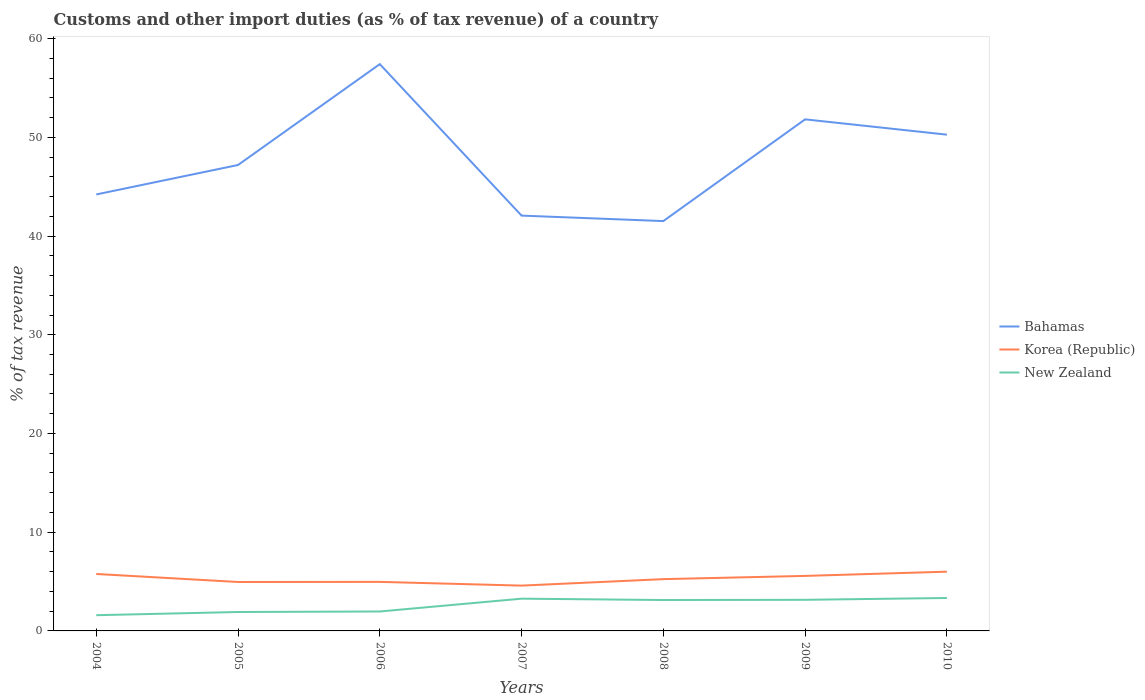Is the number of lines equal to the number of legend labels?
Your response must be concise. Yes. Across all years, what is the maximum percentage of tax revenue from customs in Korea (Republic)?
Your answer should be very brief. 4.59. What is the total percentage of tax revenue from customs in Bahamas in the graph?
Your answer should be very brief. 7.14. What is the difference between the highest and the second highest percentage of tax revenue from customs in Bahamas?
Your response must be concise. 15.9. Is the percentage of tax revenue from customs in New Zealand strictly greater than the percentage of tax revenue from customs in Bahamas over the years?
Your answer should be very brief. Yes. How many years are there in the graph?
Ensure brevity in your answer.  7. Does the graph contain any zero values?
Give a very brief answer. No. Where does the legend appear in the graph?
Keep it short and to the point. Center right. What is the title of the graph?
Offer a very short reply. Customs and other import duties (as % of tax revenue) of a country. Does "Brunei Darussalam" appear as one of the legend labels in the graph?
Offer a very short reply. No. What is the label or title of the X-axis?
Ensure brevity in your answer.  Years. What is the label or title of the Y-axis?
Ensure brevity in your answer.  % of tax revenue. What is the % of tax revenue in Bahamas in 2004?
Your answer should be compact. 44.21. What is the % of tax revenue in Korea (Republic) in 2004?
Give a very brief answer. 5.77. What is the % of tax revenue in New Zealand in 2004?
Ensure brevity in your answer.  1.59. What is the % of tax revenue in Bahamas in 2005?
Offer a very short reply. 47.2. What is the % of tax revenue of Korea (Republic) in 2005?
Offer a terse response. 4.96. What is the % of tax revenue in New Zealand in 2005?
Make the answer very short. 1.92. What is the % of tax revenue of Bahamas in 2006?
Make the answer very short. 57.42. What is the % of tax revenue of Korea (Republic) in 2006?
Provide a short and direct response. 4.97. What is the % of tax revenue in New Zealand in 2006?
Keep it short and to the point. 1.97. What is the % of tax revenue of Bahamas in 2007?
Your response must be concise. 42.07. What is the % of tax revenue of Korea (Republic) in 2007?
Your answer should be very brief. 4.59. What is the % of tax revenue of New Zealand in 2007?
Your answer should be compact. 3.27. What is the % of tax revenue of Bahamas in 2008?
Your answer should be very brief. 41.52. What is the % of tax revenue of Korea (Republic) in 2008?
Offer a very short reply. 5.25. What is the % of tax revenue of New Zealand in 2008?
Provide a short and direct response. 3.13. What is the % of tax revenue in Bahamas in 2009?
Provide a short and direct response. 51.82. What is the % of tax revenue in Korea (Republic) in 2009?
Offer a very short reply. 5.57. What is the % of tax revenue in New Zealand in 2009?
Provide a short and direct response. 3.15. What is the % of tax revenue of Bahamas in 2010?
Your answer should be very brief. 50.27. What is the % of tax revenue of Korea (Republic) in 2010?
Make the answer very short. 6. What is the % of tax revenue in New Zealand in 2010?
Provide a short and direct response. 3.34. Across all years, what is the maximum % of tax revenue of Bahamas?
Ensure brevity in your answer.  57.42. Across all years, what is the maximum % of tax revenue in Korea (Republic)?
Ensure brevity in your answer.  6. Across all years, what is the maximum % of tax revenue of New Zealand?
Provide a short and direct response. 3.34. Across all years, what is the minimum % of tax revenue in Bahamas?
Your answer should be compact. 41.52. Across all years, what is the minimum % of tax revenue in Korea (Republic)?
Offer a terse response. 4.59. Across all years, what is the minimum % of tax revenue in New Zealand?
Provide a succinct answer. 1.59. What is the total % of tax revenue in Bahamas in the graph?
Provide a short and direct response. 334.51. What is the total % of tax revenue in Korea (Republic) in the graph?
Your response must be concise. 37.1. What is the total % of tax revenue in New Zealand in the graph?
Your answer should be compact. 18.36. What is the difference between the % of tax revenue of Bahamas in 2004 and that in 2005?
Offer a very short reply. -2.98. What is the difference between the % of tax revenue of Korea (Republic) in 2004 and that in 2005?
Make the answer very short. 0.81. What is the difference between the % of tax revenue of New Zealand in 2004 and that in 2005?
Offer a terse response. -0.32. What is the difference between the % of tax revenue of Bahamas in 2004 and that in 2006?
Provide a succinct answer. -13.2. What is the difference between the % of tax revenue of Korea (Republic) in 2004 and that in 2006?
Provide a short and direct response. 0.8. What is the difference between the % of tax revenue of New Zealand in 2004 and that in 2006?
Offer a terse response. -0.38. What is the difference between the % of tax revenue of Bahamas in 2004 and that in 2007?
Offer a terse response. 2.14. What is the difference between the % of tax revenue of Korea (Republic) in 2004 and that in 2007?
Give a very brief answer. 1.18. What is the difference between the % of tax revenue of New Zealand in 2004 and that in 2007?
Give a very brief answer. -1.67. What is the difference between the % of tax revenue in Bahamas in 2004 and that in 2008?
Your answer should be very brief. 2.7. What is the difference between the % of tax revenue of Korea (Republic) in 2004 and that in 2008?
Give a very brief answer. 0.52. What is the difference between the % of tax revenue of New Zealand in 2004 and that in 2008?
Your answer should be compact. -1.54. What is the difference between the % of tax revenue of Bahamas in 2004 and that in 2009?
Keep it short and to the point. -7.61. What is the difference between the % of tax revenue of Korea (Republic) in 2004 and that in 2009?
Provide a short and direct response. 0.2. What is the difference between the % of tax revenue of New Zealand in 2004 and that in 2009?
Give a very brief answer. -1.56. What is the difference between the % of tax revenue of Bahamas in 2004 and that in 2010?
Keep it short and to the point. -6.06. What is the difference between the % of tax revenue in Korea (Republic) in 2004 and that in 2010?
Your answer should be very brief. -0.23. What is the difference between the % of tax revenue of New Zealand in 2004 and that in 2010?
Your response must be concise. -1.74. What is the difference between the % of tax revenue of Bahamas in 2005 and that in 2006?
Your answer should be compact. -10.22. What is the difference between the % of tax revenue of Korea (Republic) in 2005 and that in 2006?
Keep it short and to the point. -0.01. What is the difference between the % of tax revenue in New Zealand in 2005 and that in 2006?
Your response must be concise. -0.05. What is the difference between the % of tax revenue of Bahamas in 2005 and that in 2007?
Make the answer very short. 5.13. What is the difference between the % of tax revenue of Korea (Republic) in 2005 and that in 2007?
Offer a very short reply. 0.37. What is the difference between the % of tax revenue of New Zealand in 2005 and that in 2007?
Your response must be concise. -1.35. What is the difference between the % of tax revenue in Bahamas in 2005 and that in 2008?
Keep it short and to the point. 5.68. What is the difference between the % of tax revenue in Korea (Republic) in 2005 and that in 2008?
Provide a succinct answer. -0.29. What is the difference between the % of tax revenue of New Zealand in 2005 and that in 2008?
Give a very brief answer. -1.21. What is the difference between the % of tax revenue in Bahamas in 2005 and that in 2009?
Offer a very short reply. -4.62. What is the difference between the % of tax revenue in Korea (Republic) in 2005 and that in 2009?
Make the answer very short. -0.62. What is the difference between the % of tax revenue of New Zealand in 2005 and that in 2009?
Keep it short and to the point. -1.23. What is the difference between the % of tax revenue in Bahamas in 2005 and that in 2010?
Your answer should be very brief. -3.07. What is the difference between the % of tax revenue of Korea (Republic) in 2005 and that in 2010?
Your response must be concise. -1.05. What is the difference between the % of tax revenue of New Zealand in 2005 and that in 2010?
Provide a succinct answer. -1.42. What is the difference between the % of tax revenue in Bahamas in 2006 and that in 2007?
Offer a very short reply. 15.35. What is the difference between the % of tax revenue of Korea (Republic) in 2006 and that in 2007?
Provide a succinct answer. 0.38. What is the difference between the % of tax revenue in New Zealand in 2006 and that in 2007?
Your answer should be compact. -1.3. What is the difference between the % of tax revenue in Bahamas in 2006 and that in 2008?
Make the answer very short. 15.9. What is the difference between the % of tax revenue of Korea (Republic) in 2006 and that in 2008?
Offer a very short reply. -0.28. What is the difference between the % of tax revenue in New Zealand in 2006 and that in 2008?
Make the answer very short. -1.16. What is the difference between the % of tax revenue of Bahamas in 2006 and that in 2009?
Give a very brief answer. 5.59. What is the difference between the % of tax revenue of Korea (Republic) in 2006 and that in 2009?
Offer a very short reply. -0.6. What is the difference between the % of tax revenue of New Zealand in 2006 and that in 2009?
Your response must be concise. -1.18. What is the difference between the % of tax revenue in Bahamas in 2006 and that in 2010?
Keep it short and to the point. 7.14. What is the difference between the % of tax revenue in Korea (Republic) in 2006 and that in 2010?
Offer a very short reply. -1.03. What is the difference between the % of tax revenue in New Zealand in 2006 and that in 2010?
Provide a short and direct response. -1.37. What is the difference between the % of tax revenue of Bahamas in 2007 and that in 2008?
Your answer should be compact. 0.55. What is the difference between the % of tax revenue in Korea (Republic) in 2007 and that in 2008?
Your answer should be very brief. -0.66. What is the difference between the % of tax revenue of New Zealand in 2007 and that in 2008?
Give a very brief answer. 0.14. What is the difference between the % of tax revenue in Bahamas in 2007 and that in 2009?
Your answer should be very brief. -9.75. What is the difference between the % of tax revenue of Korea (Republic) in 2007 and that in 2009?
Offer a very short reply. -0.98. What is the difference between the % of tax revenue in New Zealand in 2007 and that in 2009?
Your response must be concise. 0.11. What is the difference between the % of tax revenue in Bahamas in 2007 and that in 2010?
Ensure brevity in your answer.  -8.2. What is the difference between the % of tax revenue in Korea (Republic) in 2007 and that in 2010?
Keep it short and to the point. -1.41. What is the difference between the % of tax revenue of New Zealand in 2007 and that in 2010?
Your answer should be compact. -0.07. What is the difference between the % of tax revenue of Bahamas in 2008 and that in 2009?
Your answer should be very brief. -10.3. What is the difference between the % of tax revenue of Korea (Republic) in 2008 and that in 2009?
Keep it short and to the point. -0.33. What is the difference between the % of tax revenue of New Zealand in 2008 and that in 2009?
Give a very brief answer. -0.02. What is the difference between the % of tax revenue of Bahamas in 2008 and that in 2010?
Provide a succinct answer. -8.75. What is the difference between the % of tax revenue in Korea (Republic) in 2008 and that in 2010?
Provide a short and direct response. -0.76. What is the difference between the % of tax revenue of New Zealand in 2008 and that in 2010?
Your answer should be very brief. -0.21. What is the difference between the % of tax revenue of Bahamas in 2009 and that in 2010?
Your answer should be compact. 1.55. What is the difference between the % of tax revenue in Korea (Republic) in 2009 and that in 2010?
Your response must be concise. -0.43. What is the difference between the % of tax revenue in New Zealand in 2009 and that in 2010?
Make the answer very short. -0.18. What is the difference between the % of tax revenue in Bahamas in 2004 and the % of tax revenue in Korea (Republic) in 2005?
Offer a very short reply. 39.26. What is the difference between the % of tax revenue in Bahamas in 2004 and the % of tax revenue in New Zealand in 2005?
Your response must be concise. 42.3. What is the difference between the % of tax revenue in Korea (Republic) in 2004 and the % of tax revenue in New Zealand in 2005?
Make the answer very short. 3.85. What is the difference between the % of tax revenue of Bahamas in 2004 and the % of tax revenue of Korea (Republic) in 2006?
Ensure brevity in your answer.  39.25. What is the difference between the % of tax revenue of Bahamas in 2004 and the % of tax revenue of New Zealand in 2006?
Give a very brief answer. 42.25. What is the difference between the % of tax revenue in Korea (Republic) in 2004 and the % of tax revenue in New Zealand in 2006?
Give a very brief answer. 3.8. What is the difference between the % of tax revenue in Bahamas in 2004 and the % of tax revenue in Korea (Republic) in 2007?
Your response must be concise. 39.62. What is the difference between the % of tax revenue in Bahamas in 2004 and the % of tax revenue in New Zealand in 2007?
Offer a very short reply. 40.95. What is the difference between the % of tax revenue of Korea (Republic) in 2004 and the % of tax revenue of New Zealand in 2007?
Your answer should be compact. 2.5. What is the difference between the % of tax revenue in Bahamas in 2004 and the % of tax revenue in Korea (Republic) in 2008?
Ensure brevity in your answer.  38.97. What is the difference between the % of tax revenue of Bahamas in 2004 and the % of tax revenue of New Zealand in 2008?
Give a very brief answer. 41.08. What is the difference between the % of tax revenue of Korea (Republic) in 2004 and the % of tax revenue of New Zealand in 2008?
Give a very brief answer. 2.64. What is the difference between the % of tax revenue in Bahamas in 2004 and the % of tax revenue in Korea (Republic) in 2009?
Make the answer very short. 38.64. What is the difference between the % of tax revenue in Bahamas in 2004 and the % of tax revenue in New Zealand in 2009?
Your response must be concise. 41.06. What is the difference between the % of tax revenue in Korea (Republic) in 2004 and the % of tax revenue in New Zealand in 2009?
Provide a short and direct response. 2.62. What is the difference between the % of tax revenue in Bahamas in 2004 and the % of tax revenue in Korea (Republic) in 2010?
Provide a succinct answer. 38.21. What is the difference between the % of tax revenue of Bahamas in 2004 and the % of tax revenue of New Zealand in 2010?
Your answer should be very brief. 40.88. What is the difference between the % of tax revenue in Korea (Republic) in 2004 and the % of tax revenue in New Zealand in 2010?
Provide a short and direct response. 2.43. What is the difference between the % of tax revenue of Bahamas in 2005 and the % of tax revenue of Korea (Republic) in 2006?
Keep it short and to the point. 42.23. What is the difference between the % of tax revenue in Bahamas in 2005 and the % of tax revenue in New Zealand in 2006?
Keep it short and to the point. 45.23. What is the difference between the % of tax revenue in Korea (Republic) in 2005 and the % of tax revenue in New Zealand in 2006?
Offer a very short reply. 2.99. What is the difference between the % of tax revenue in Bahamas in 2005 and the % of tax revenue in Korea (Republic) in 2007?
Provide a succinct answer. 42.61. What is the difference between the % of tax revenue of Bahamas in 2005 and the % of tax revenue of New Zealand in 2007?
Your answer should be very brief. 43.93. What is the difference between the % of tax revenue in Korea (Republic) in 2005 and the % of tax revenue in New Zealand in 2007?
Offer a very short reply. 1.69. What is the difference between the % of tax revenue in Bahamas in 2005 and the % of tax revenue in Korea (Republic) in 2008?
Your answer should be compact. 41.95. What is the difference between the % of tax revenue in Bahamas in 2005 and the % of tax revenue in New Zealand in 2008?
Keep it short and to the point. 44.07. What is the difference between the % of tax revenue in Korea (Republic) in 2005 and the % of tax revenue in New Zealand in 2008?
Your answer should be very brief. 1.83. What is the difference between the % of tax revenue in Bahamas in 2005 and the % of tax revenue in Korea (Republic) in 2009?
Offer a very short reply. 41.62. What is the difference between the % of tax revenue of Bahamas in 2005 and the % of tax revenue of New Zealand in 2009?
Your response must be concise. 44.05. What is the difference between the % of tax revenue of Korea (Republic) in 2005 and the % of tax revenue of New Zealand in 2009?
Give a very brief answer. 1.8. What is the difference between the % of tax revenue in Bahamas in 2005 and the % of tax revenue in Korea (Republic) in 2010?
Offer a terse response. 41.2. What is the difference between the % of tax revenue in Bahamas in 2005 and the % of tax revenue in New Zealand in 2010?
Ensure brevity in your answer.  43.86. What is the difference between the % of tax revenue of Korea (Republic) in 2005 and the % of tax revenue of New Zealand in 2010?
Your response must be concise. 1.62. What is the difference between the % of tax revenue of Bahamas in 2006 and the % of tax revenue of Korea (Republic) in 2007?
Keep it short and to the point. 52.83. What is the difference between the % of tax revenue of Bahamas in 2006 and the % of tax revenue of New Zealand in 2007?
Your answer should be compact. 54.15. What is the difference between the % of tax revenue in Korea (Republic) in 2006 and the % of tax revenue in New Zealand in 2007?
Make the answer very short. 1.7. What is the difference between the % of tax revenue of Bahamas in 2006 and the % of tax revenue of Korea (Republic) in 2008?
Ensure brevity in your answer.  52.17. What is the difference between the % of tax revenue in Bahamas in 2006 and the % of tax revenue in New Zealand in 2008?
Your response must be concise. 54.28. What is the difference between the % of tax revenue in Korea (Republic) in 2006 and the % of tax revenue in New Zealand in 2008?
Offer a very short reply. 1.84. What is the difference between the % of tax revenue in Bahamas in 2006 and the % of tax revenue in Korea (Republic) in 2009?
Keep it short and to the point. 51.84. What is the difference between the % of tax revenue of Bahamas in 2006 and the % of tax revenue of New Zealand in 2009?
Provide a succinct answer. 54.26. What is the difference between the % of tax revenue of Korea (Republic) in 2006 and the % of tax revenue of New Zealand in 2009?
Offer a terse response. 1.82. What is the difference between the % of tax revenue in Bahamas in 2006 and the % of tax revenue in Korea (Republic) in 2010?
Offer a very short reply. 51.41. What is the difference between the % of tax revenue of Bahamas in 2006 and the % of tax revenue of New Zealand in 2010?
Your answer should be very brief. 54.08. What is the difference between the % of tax revenue in Korea (Republic) in 2006 and the % of tax revenue in New Zealand in 2010?
Offer a very short reply. 1.63. What is the difference between the % of tax revenue of Bahamas in 2007 and the % of tax revenue of Korea (Republic) in 2008?
Your response must be concise. 36.82. What is the difference between the % of tax revenue in Bahamas in 2007 and the % of tax revenue in New Zealand in 2008?
Your answer should be very brief. 38.94. What is the difference between the % of tax revenue in Korea (Republic) in 2007 and the % of tax revenue in New Zealand in 2008?
Your answer should be very brief. 1.46. What is the difference between the % of tax revenue in Bahamas in 2007 and the % of tax revenue in Korea (Republic) in 2009?
Offer a very short reply. 36.5. What is the difference between the % of tax revenue in Bahamas in 2007 and the % of tax revenue in New Zealand in 2009?
Provide a succinct answer. 38.92. What is the difference between the % of tax revenue of Korea (Republic) in 2007 and the % of tax revenue of New Zealand in 2009?
Make the answer very short. 1.44. What is the difference between the % of tax revenue in Bahamas in 2007 and the % of tax revenue in Korea (Republic) in 2010?
Your answer should be compact. 36.07. What is the difference between the % of tax revenue of Bahamas in 2007 and the % of tax revenue of New Zealand in 2010?
Provide a short and direct response. 38.73. What is the difference between the % of tax revenue in Korea (Republic) in 2007 and the % of tax revenue in New Zealand in 2010?
Give a very brief answer. 1.25. What is the difference between the % of tax revenue in Bahamas in 2008 and the % of tax revenue in Korea (Republic) in 2009?
Your answer should be compact. 35.94. What is the difference between the % of tax revenue in Bahamas in 2008 and the % of tax revenue in New Zealand in 2009?
Your answer should be very brief. 38.37. What is the difference between the % of tax revenue in Korea (Republic) in 2008 and the % of tax revenue in New Zealand in 2009?
Provide a succinct answer. 2.09. What is the difference between the % of tax revenue in Bahamas in 2008 and the % of tax revenue in Korea (Republic) in 2010?
Your answer should be compact. 35.52. What is the difference between the % of tax revenue in Bahamas in 2008 and the % of tax revenue in New Zealand in 2010?
Ensure brevity in your answer.  38.18. What is the difference between the % of tax revenue in Korea (Republic) in 2008 and the % of tax revenue in New Zealand in 2010?
Ensure brevity in your answer.  1.91. What is the difference between the % of tax revenue of Bahamas in 2009 and the % of tax revenue of Korea (Republic) in 2010?
Provide a short and direct response. 45.82. What is the difference between the % of tax revenue of Bahamas in 2009 and the % of tax revenue of New Zealand in 2010?
Your response must be concise. 48.48. What is the difference between the % of tax revenue in Korea (Republic) in 2009 and the % of tax revenue in New Zealand in 2010?
Provide a short and direct response. 2.24. What is the average % of tax revenue in Bahamas per year?
Offer a terse response. 47.79. What is the average % of tax revenue in Korea (Republic) per year?
Ensure brevity in your answer.  5.3. What is the average % of tax revenue of New Zealand per year?
Give a very brief answer. 2.62. In the year 2004, what is the difference between the % of tax revenue of Bahamas and % of tax revenue of Korea (Republic)?
Your answer should be compact. 38.44. In the year 2004, what is the difference between the % of tax revenue in Bahamas and % of tax revenue in New Zealand?
Your answer should be very brief. 42.62. In the year 2004, what is the difference between the % of tax revenue of Korea (Republic) and % of tax revenue of New Zealand?
Give a very brief answer. 4.18. In the year 2005, what is the difference between the % of tax revenue of Bahamas and % of tax revenue of Korea (Republic)?
Offer a very short reply. 42.24. In the year 2005, what is the difference between the % of tax revenue in Bahamas and % of tax revenue in New Zealand?
Offer a terse response. 45.28. In the year 2005, what is the difference between the % of tax revenue of Korea (Republic) and % of tax revenue of New Zealand?
Offer a terse response. 3.04. In the year 2006, what is the difference between the % of tax revenue of Bahamas and % of tax revenue of Korea (Republic)?
Ensure brevity in your answer.  52.45. In the year 2006, what is the difference between the % of tax revenue of Bahamas and % of tax revenue of New Zealand?
Offer a terse response. 55.45. In the year 2006, what is the difference between the % of tax revenue in Korea (Republic) and % of tax revenue in New Zealand?
Ensure brevity in your answer.  3. In the year 2007, what is the difference between the % of tax revenue of Bahamas and % of tax revenue of Korea (Republic)?
Ensure brevity in your answer.  37.48. In the year 2007, what is the difference between the % of tax revenue in Bahamas and % of tax revenue in New Zealand?
Provide a short and direct response. 38.8. In the year 2007, what is the difference between the % of tax revenue in Korea (Republic) and % of tax revenue in New Zealand?
Provide a short and direct response. 1.32. In the year 2008, what is the difference between the % of tax revenue in Bahamas and % of tax revenue in Korea (Republic)?
Your response must be concise. 36.27. In the year 2008, what is the difference between the % of tax revenue of Bahamas and % of tax revenue of New Zealand?
Your response must be concise. 38.39. In the year 2008, what is the difference between the % of tax revenue in Korea (Republic) and % of tax revenue in New Zealand?
Offer a terse response. 2.12. In the year 2009, what is the difference between the % of tax revenue in Bahamas and % of tax revenue in Korea (Republic)?
Provide a succinct answer. 46.25. In the year 2009, what is the difference between the % of tax revenue of Bahamas and % of tax revenue of New Zealand?
Your answer should be very brief. 48.67. In the year 2009, what is the difference between the % of tax revenue in Korea (Republic) and % of tax revenue in New Zealand?
Your response must be concise. 2.42. In the year 2010, what is the difference between the % of tax revenue of Bahamas and % of tax revenue of Korea (Republic)?
Give a very brief answer. 44.27. In the year 2010, what is the difference between the % of tax revenue of Bahamas and % of tax revenue of New Zealand?
Keep it short and to the point. 46.93. In the year 2010, what is the difference between the % of tax revenue of Korea (Republic) and % of tax revenue of New Zealand?
Keep it short and to the point. 2.67. What is the ratio of the % of tax revenue of Bahamas in 2004 to that in 2005?
Give a very brief answer. 0.94. What is the ratio of the % of tax revenue of Korea (Republic) in 2004 to that in 2005?
Your response must be concise. 1.16. What is the ratio of the % of tax revenue in New Zealand in 2004 to that in 2005?
Make the answer very short. 0.83. What is the ratio of the % of tax revenue of Bahamas in 2004 to that in 2006?
Your response must be concise. 0.77. What is the ratio of the % of tax revenue of Korea (Republic) in 2004 to that in 2006?
Offer a very short reply. 1.16. What is the ratio of the % of tax revenue in New Zealand in 2004 to that in 2006?
Offer a terse response. 0.81. What is the ratio of the % of tax revenue in Bahamas in 2004 to that in 2007?
Offer a very short reply. 1.05. What is the ratio of the % of tax revenue of Korea (Republic) in 2004 to that in 2007?
Provide a short and direct response. 1.26. What is the ratio of the % of tax revenue in New Zealand in 2004 to that in 2007?
Your response must be concise. 0.49. What is the ratio of the % of tax revenue in Bahamas in 2004 to that in 2008?
Give a very brief answer. 1.06. What is the ratio of the % of tax revenue of Korea (Republic) in 2004 to that in 2008?
Offer a terse response. 1.1. What is the ratio of the % of tax revenue of New Zealand in 2004 to that in 2008?
Give a very brief answer. 0.51. What is the ratio of the % of tax revenue in Bahamas in 2004 to that in 2009?
Your answer should be very brief. 0.85. What is the ratio of the % of tax revenue in Korea (Republic) in 2004 to that in 2009?
Your answer should be compact. 1.04. What is the ratio of the % of tax revenue of New Zealand in 2004 to that in 2009?
Keep it short and to the point. 0.51. What is the ratio of the % of tax revenue in Bahamas in 2004 to that in 2010?
Keep it short and to the point. 0.88. What is the ratio of the % of tax revenue in Korea (Republic) in 2004 to that in 2010?
Make the answer very short. 0.96. What is the ratio of the % of tax revenue in New Zealand in 2004 to that in 2010?
Your answer should be compact. 0.48. What is the ratio of the % of tax revenue in Bahamas in 2005 to that in 2006?
Your answer should be very brief. 0.82. What is the ratio of the % of tax revenue of New Zealand in 2005 to that in 2006?
Give a very brief answer. 0.97. What is the ratio of the % of tax revenue in Bahamas in 2005 to that in 2007?
Your response must be concise. 1.12. What is the ratio of the % of tax revenue in Korea (Republic) in 2005 to that in 2007?
Ensure brevity in your answer.  1.08. What is the ratio of the % of tax revenue in New Zealand in 2005 to that in 2007?
Your answer should be compact. 0.59. What is the ratio of the % of tax revenue of Bahamas in 2005 to that in 2008?
Your answer should be very brief. 1.14. What is the ratio of the % of tax revenue in Korea (Republic) in 2005 to that in 2008?
Your response must be concise. 0.94. What is the ratio of the % of tax revenue in New Zealand in 2005 to that in 2008?
Make the answer very short. 0.61. What is the ratio of the % of tax revenue in Bahamas in 2005 to that in 2009?
Provide a short and direct response. 0.91. What is the ratio of the % of tax revenue in Korea (Republic) in 2005 to that in 2009?
Offer a terse response. 0.89. What is the ratio of the % of tax revenue of New Zealand in 2005 to that in 2009?
Offer a very short reply. 0.61. What is the ratio of the % of tax revenue in Bahamas in 2005 to that in 2010?
Your answer should be very brief. 0.94. What is the ratio of the % of tax revenue in Korea (Republic) in 2005 to that in 2010?
Your answer should be compact. 0.83. What is the ratio of the % of tax revenue in New Zealand in 2005 to that in 2010?
Offer a terse response. 0.57. What is the ratio of the % of tax revenue of Bahamas in 2006 to that in 2007?
Keep it short and to the point. 1.36. What is the ratio of the % of tax revenue in Korea (Republic) in 2006 to that in 2007?
Your response must be concise. 1.08. What is the ratio of the % of tax revenue in New Zealand in 2006 to that in 2007?
Your response must be concise. 0.6. What is the ratio of the % of tax revenue in Bahamas in 2006 to that in 2008?
Give a very brief answer. 1.38. What is the ratio of the % of tax revenue in Korea (Republic) in 2006 to that in 2008?
Keep it short and to the point. 0.95. What is the ratio of the % of tax revenue in New Zealand in 2006 to that in 2008?
Keep it short and to the point. 0.63. What is the ratio of the % of tax revenue in Bahamas in 2006 to that in 2009?
Provide a succinct answer. 1.11. What is the ratio of the % of tax revenue in Korea (Republic) in 2006 to that in 2009?
Your answer should be very brief. 0.89. What is the ratio of the % of tax revenue in New Zealand in 2006 to that in 2009?
Give a very brief answer. 0.62. What is the ratio of the % of tax revenue in Bahamas in 2006 to that in 2010?
Ensure brevity in your answer.  1.14. What is the ratio of the % of tax revenue of Korea (Republic) in 2006 to that in 2010?
Offer a terse response. 0.83. What is the ratio of the % of tax revenue in New Zealand in 2006 to that in 2010?
Your answer should be compact. 0.59. What is the ratio of the % of tax revenue of Bahamas in 2007 to that in 2008?
Ensure brevity in your answer.  1.01. What is the ratio of the % of tax revenue of New Zealand in 2007 to that in 2008?
Your response must be concise. 1.04. What is the ratio of the % of tax revenue of Bahamas in 2007 to that in 2009?
Keep it short and to the point. 0.81. What is the ratio of the % of tax revenue of Korea (Republic) in 2007 to that in 2009?
Your answer should be very brief. 0.82. What is the ratio of the % of tax revenue in New Zealand in 2007 to that in 2009?
Provide a succinct answer. 1.04. What is the ratio of the % of tax revenue in Bahamas in 2007 to that in 2010?
Offer a very short reply. 0.84. What is the ratio of the % of tax revenue in Korea (Republic) in 2007 to that in 2010?
Ensure brevity in your answer.  0.76. What is the ratio of the % of tax revenue in New Zealand in 2007 to that in 2010?
Offer a terse response. 0.98. What is the ratio of the % of tax revenue of Bahamas in 2008 to that in 2009?
Offer a very short reply. 0.8. What is the ratio of the % of tax revenue in Korea (Republic) in 2008 to that in 2009?
Keep it short and to the point. 0.94. What is the ratio of the % of tax revenue in New Zealand in 2008 to that in 2009?
Provide a short and direct response. 0.99. What is the ratio of the % of tax revenue of Bahamas in 2008 to that in 2010?
Keep it short and to the point. 0.83. What is the ratio of the % of tax revenue in Korea (Republic) in 2008 to that in 2010?
Ensure brevity in your answer.  0.87. What is the ratio of the % of tax revenue in New Zealand in 2008 to that in 2010?
Give a very brief answer. 0.94. What is the ratio of the % of tax revenue in Bahamas in 2009 to that in 2010?
Keep it short and to the point. 1.03. What is the ratio of the % of tax revenue in Korea (Republic) in 2009 to that in 2010?
Provide a succinct answer. 0.93. What is the ratio of the % of tax revenue in New Zealand in 2009 to that in 2010?
Keep it short and to the point. 0.94. What is the difference between the highest and the second highest % of tax revenue of Bahamas?
Offer a very short reply. 5.59. What is the difference between the highest and the second highest % of tax revenue in Korea (Republic)?
Make the answer very short. 0.23. What is the difference between the highest and the second highest % of tax revenue in New Zealand?
Provide a short and direct response. 0.07. What is the difference between the highest and the lowest % of tax revenue in Bahamas?
Provide a short and direct response. 15.9. What is the difference between the highest and the lowest % of tax revenue in Korea (Republic)?
Provide a succinct answer. 1.41. What is the difference between the highest and the lowest % of tax revenue in New Zealand?
Your answer should be very brief. 1.74. 